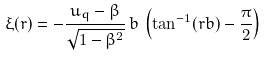<formula> <loc_0><loc_0><loc_500><loc_500>\xi ( r ) = - \frac { u _ { q } - \beta } { \sqrt { 1 - \beta ^ { 2 } } } \, b \, \left ( \tan ^ { - 1 } ( r b ) - \frac { \pi } { 2 } \right )</formula> 